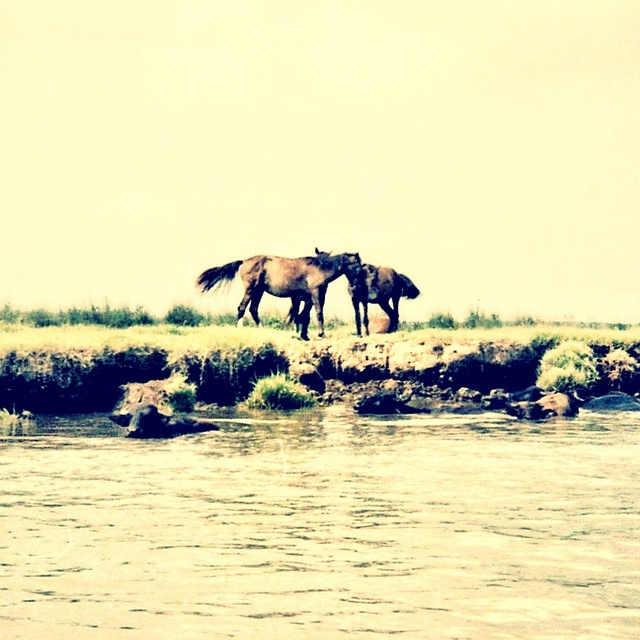Describe the objects in this image and their specific colors. I can see horse in lightyellow, navy, tan, and gray tones, horse in lightyellow, navy, gray, and darkgray tones, cow in lightyellow, navy, darkgray, and gray tones, cow in lightyellow, navy, tan, and gray tones, and cow in lightyellow, navy, blue, and gray tones in this image. 